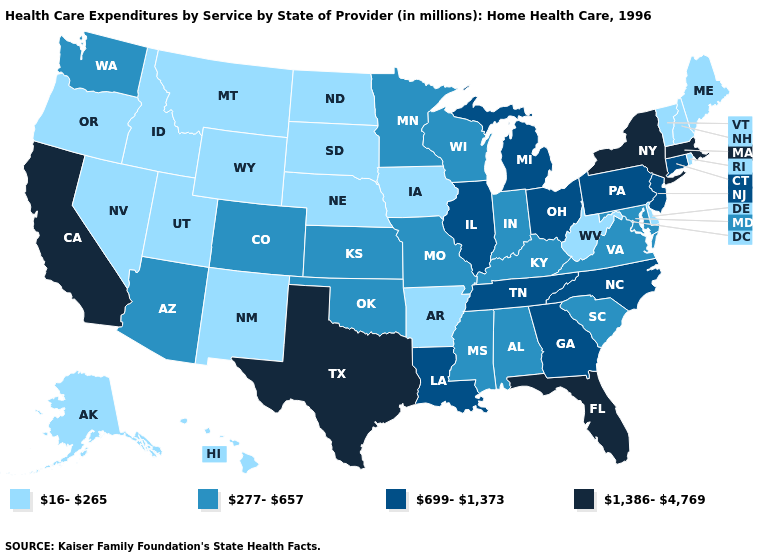Among the states that border Colorado , does Oklahoma have the lowest value?
Short answer required. No. What is the value of South Dakota?
Quick response, please. 16-265. Name the states that have a value in the range 16-265?
Concise answer only. Alaska, Arkansas, Delaware, Hawaii, Idaho, Iowa, Maine, Montana, Nebraska, Nevada, New Hampshire, New Mexico, North Dakota, Oregon, Rhode Island, South Dakota, Utah, Vermont, West Virginia, Wyoming. Does Hawaii have a lower value than Washington?
Be succinct. Yes. Which states have the highest value in the USA?
Give a very brief answer. California, Florida, Massachusetts, New York, Texas. Among the states that border Rhode Island , which have the highest value?
Answer briefly. Massachusetts. Does Vermont have the same value as Louisiana?
Keep it brief. No. What is the lowest value in states that border Georgia?
Concise answer only. 277-657. Is the legend a continuous bar?
Short answer required. No. Name the states that have a value in the range 1,386-4,769?
Quick response, please. California, Florida, Massachusetts, New York, Texas. Does Oregon have the lowest value in the West?
Keep it brief. Yes. What is the lowest value in the West?
Concise answer only. 16-265. What is the value of New York?
Give a very brief answer. 1,386-4,769. Name the states that have a value in the range 277-657?
Be succinct. Alabama, Arizona, Colorado, Indiana, Kansas, Kentucky, Maryland, Minnesota, Mississippi, Missouri, Oklahoma, South Carolina, Virginia, Washington, Wisconsin. Does Kansas have the highest value in the MidWest?
Keep it brief. No. 